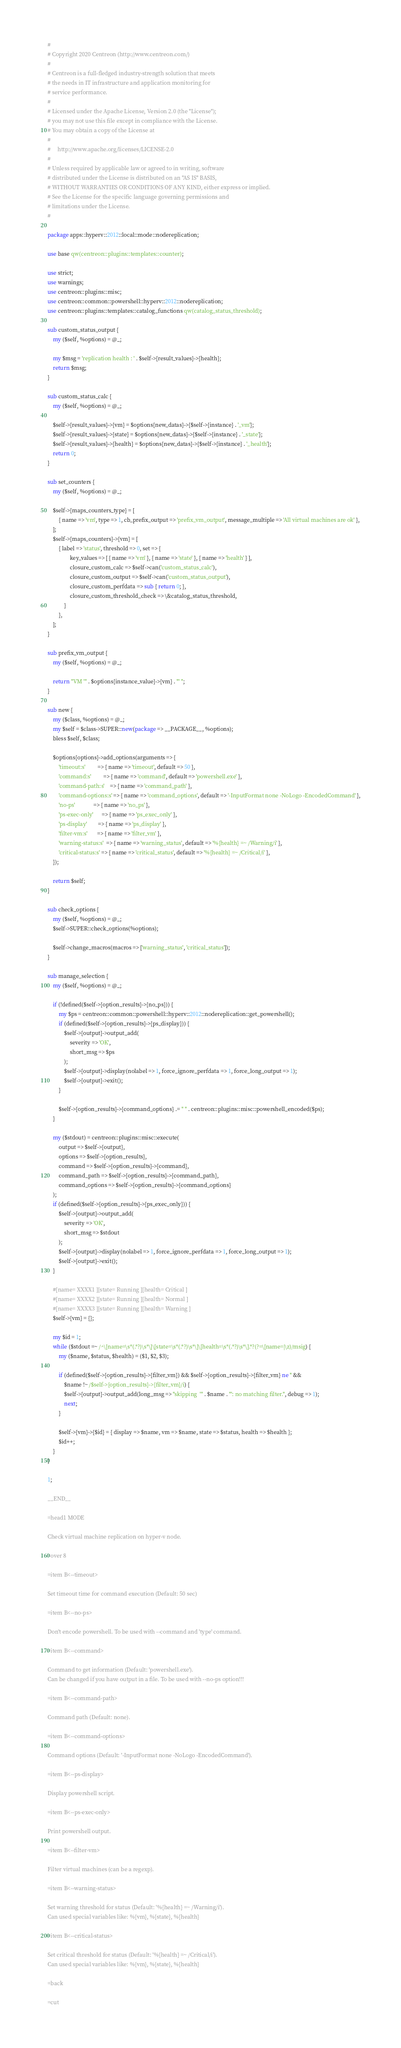Convert code to text. <code><loc_0><loc_0><loc_500><loc_500><_Perl_>#
# Copyright 2020 Centreon (http://www.centreon.com/)
#
# Centreon is a full-fledged industry-strength solution that meets
# the needs in IT infrastructure and application monitoring for
# service performance.
#
# Licensed under the Apache License, Version 2.0 (the "License");
# you may not use this file except in compliance with the License.
# You may obtain a copy of the License at
#
#     http://www.apache.org/licenses/LICENSE-2.0
#
# Unless required by applicable law or agreed to in writing, software
# distributed under the License is distributed on an "AS IS" BASIS,
# WITHOUT WARRANTIES OR CONDITIONS OF ANY KIND, either express or implied.
# See the License for the specific language governing permissions and
# limitations under the License.
#

package apps::hyperv::2012::local::mode::nodereplication;

use base qw(centreon::plugins::templates::counter);

use strict;
use warnings;
use centreon::plugins::misc;
use centreon::common::powershell::hyperv::2012::nodereplication;
use centreon::plugins::templates::catalog_functions qw(catalog_status_threshold);

sub custom_status_output {
    my ($self, %options) = @_;
    
    my $msg = 'replication health : ' . $self->{result_values}->{health};
    return $msg;
}

sub custom_status_calc {
    my ($self, %options) = @_;
    
    $self->{result_values}->{vm} = $options{new_datas}->{$self->{instance} . '_vm'};
    $self->{result_values}->{state} = $options{new_datas}->{$self->{instance} . '_state'};
    $self->{result_values}->{health} = $options{new_datas}->{$self->{instance} . '_health'};
    return 0;
}

sub set_counters {
    my ($self, %options) = @_;
    
    $self->{maps_counters_type} = [
        { name => 'vm', type => 1, cb_prefix_output => 'prefix_vm_output', message_multiple => 'All virtual machines are ok' },
    ];
    $self->{maps_counters}->{vm} = [
        { label => 'status', threshold => 0, set => {
                key_values => [ { name => 'vm' }, { name => 'state' }, { name => 'health' } ],
                closure_custom_calc => $self->can('custom_status_calc'),
                closure_custom_output => $self->can('custom_status_output'),
                closure_custom_perfdata => sub { return 0; },
                closure_custom_threshold_check => \&catalog_status_threshold,
            }
        },
    ];
}

sub prefix_vm_output {
    my ($self, %options) = @_;
    
    return "VM '" . $options{instance_value}->{vm} . "' ";
}

sub new {
    my ($class, %options) = @_;
    my $self = $class->SUPER::new(package => __PACKAGE__, %options);
    bless $self, $class;

    $options{options}->add_options(arguments => {
        'timeout:s'         => { name => 'timeout', default => 50 },
        'command:s'         => { name => 'command', default => 'powershell.exe' },
        'command-path:s'    => { name => 'command_path' },
        'command-options:s' => { name => 'command_options', default => '-InputFormat none -NoLogo -EncodedCommand' },
        'no-ps'             => { name => 'no_ps' },
        'ps-exec-only'      => { name => 'ps_exec_only' },
        'ps-display'        => { name => 'ps_display' },
        'filter-vm:s'       => { name => 'filter_vm' },
        'warning-status:s'  => { name => 'warning_status', default => '%{health} =~ /Warning/i' },
        'critical-status:s' => { name => 'critical_status', default => '%{health} =~ /Critical/i' },
    });

    return $self;
}

sub check_options {
    my ($self, %options) = @_;
    $self->SUPER::check_options(%options);  

    $self->change_macros(macros => ['warning_status', 'critical_status']);
}

sub manage_selection {
    my ($self, %options) = @_;

    if (!defined($self->{option_results}->{no_ps})) {
        my $ps = centreon::common::powershell::hyperv::2012::nodereplication::get_powershell();
        if (defined($self->{option_results}->{ps_display})) {
            $self->{output}->output_add(
                severity => 'OK',
                short_msg => $ps
            );
            $self->{output}->display(nolabel => 1, force_ignore_perfdata => 1, force_long_output => 1);
            $self->{output}->exit();
        }

        $self->{option_results}->{command_options} .= " " . centreon::plugins::misc::powershell_encoded($ps);
    }
    
    my ($stdout) = centreon::plugins::misc::execute(
        output => $self->{output},
        options => $self->{option_results},
        command => $self->{option_results}->{command},
        command_path => $self->{option_results}->{command_path},
        command_options => $self->{option_results}->{command_options}
    );
    if (defined($self->{option_results}->{ps_exec_only})) {
        $self->{output}->output_add(
            severity => 'OK',
            short_msg => $stdout
        );
        $self->{output}->display(nolabel => 1, force_ignore_perfdata => 1, force_long_output => 1);
        $self->{output}->exit();
    }
    
    #[name= XXXX1 ][state= Running ][health= Critical ]
    #[name= XXXX2 ][state= Running ][health= Normal ]
    #[name= XXXX3 ][state= Running ][health= Warning ]
    $self->{vm} = {};
    
    my $id = 1;
    while ($stdout =~ /^\[name=\s*(.*?)\s*\]\[state=\s*(.*?)\s*\]\[health=\s*(.*?)\s*\].*?(?=\[name=|\z)/msig) {
        my ($name, $status, $health) = ($1, $2, $3);

        if (defined($self->{option_results}->{filter_vm}) && $self->{option_results}->{filter_vm} ne '' &&
            $name !~ /$self->{option_results}->{filter_vm}/i) {
            $self->{output}->output_add(long_msg => "skipping  '" . $name . "': no matching filter.", debug => 1);
            next;
        }
        
        $self->{vm}->{$id} = { display => $name, vm => $name, state => $status, health => $health };
        $id++;
    }
}

1;

__END__

=head1 MODE

Check virtual machine replication on hyper-v node.

=over 8

=item B<--timeout>

Set timeout time for command execution (Default: 50 sec)

=item B<--no-ps>

Don't encode powershell. To be used with --command and 'type' command.

=item B<--command>

Command to get information (Default: 'powershell.exe').
Can be changed if you have output in a file. To be used with --no-ps option!!!

=item B<--command-path>

Command path (Default: none).

=item B<--command-options>

Command options (Default: '-InputFormat none -NoLogo -EncodedCommand').

=item B<--ps-display>

Display powershell script.

=item B<--ps-exec-only>

Print powershell output.

=item B<--filter-vm>

Filter virtual machines (can be a regexp).

=item B<--warning-status>

Set warning threshold for status (Default: '%{health} =~ /Warning/i').
Can used special variables like: %{vm}, %{state}, %{health}

=item B<--critical-status>

Set critical threshold for status (Default: '%{health} =~ /Critical/i').
Can used special variables like: %{vm}, %{state}, %{health}

=back

=cut
</code> 